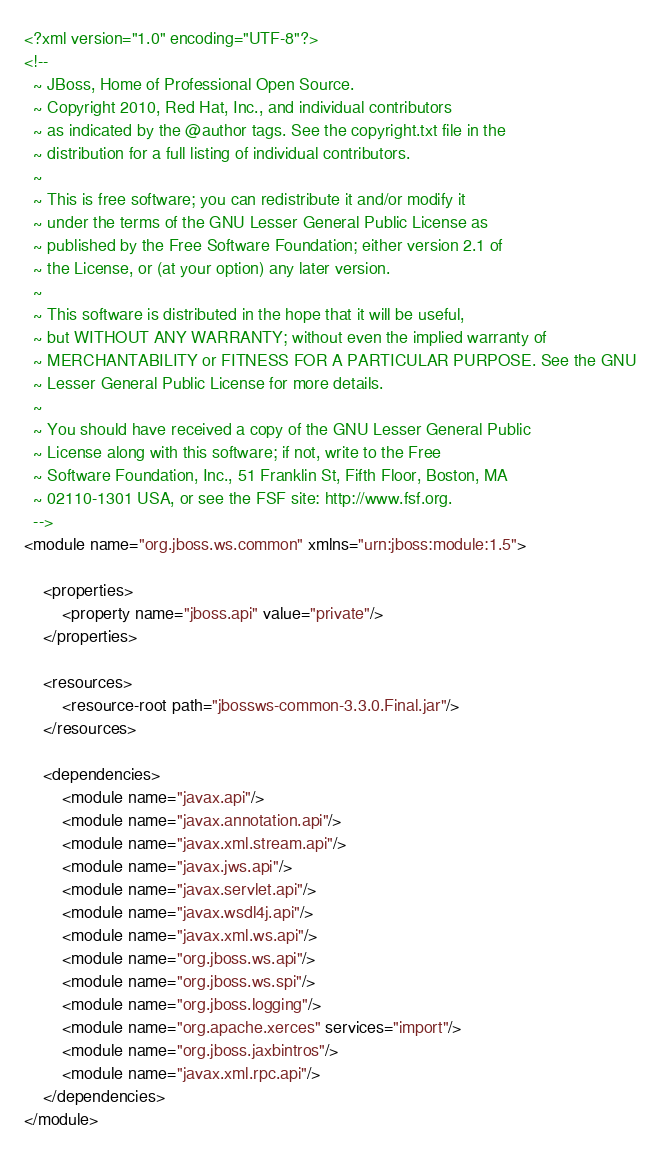Convert code to text. <code><loc_0><loc_0><loc_500><loc_500><_XML_><?xml version="1.0" encoding="UTF-8"?>
<!--
  ~ JBoss, Home of Professional Open Source.
  ~ Copyright 2010, Red Hat, Inc., and individual contributors
  ~ as indicated by the @author tags. See the copyright.txt file in the
  ~ distribution for a full listing of individual contributors.
  ~
  ~ This is free software; you can redistribute it and/or modify it
  ~ under the terms of the GNU Lesser General Public License as
  ~ published by the Free Software Foundation; either version 2.1 of
  ~ the License, or (at your option) any later version.
  ~
  ~ This software is distributed in the hope that it will be useful,
  ~ but WITHOUT ANY WARRANTY; without even the implied warranty of
  ~ MERCHANTABILITY or FITNESS FOR A PARTICULAR PURPOSE. See the GNU
  ~ Lesser General Public License for more details.
  ~
  ~ You should have received a copy of the GNU Lesser General Public
  ~ License along with this software; if not, write to the Free
  ~ Software Foundation, Inc., 51 Franklin St, Fifth Floor, Boston, MA
  ~ 02110-1301 USA, or see the FSF site: http://www.fsf.org.
  -->
<module name="org.jboss.ws.common" xmlns="urn:jboss:module:1.5">

    <properties>
        <property name="jboss.api" value="private"/>
    </properties>

    <resources>
        <resource-root path="jbossws-common-3.3.0.Final.jar"/>
    </resources>

    <dependencies>
        <module name="javax.api"/>
        <module name="javax.annotation.api"/>
        <module name="javax.xml.stream.api"/>
        <module name="javax.jws.api"/>
        <module name="javax.servlet.api"/>
        <module name="javax.wsdl4j.api"/>
        <module name="javax.xml.ws.api"/>
        <module name="org.jboss.ws.api"/>
        <module name="org.jboss.ws.spi"/>
        <module name="org.jboss.logging"/>
        <module name="org.apache.xerces" services="import"/>
        <module name="org.jboss.jaxbintros"/>
        <module name="javax.xml.rpc.api"/>
    </dependencies>
</module>
</code> 